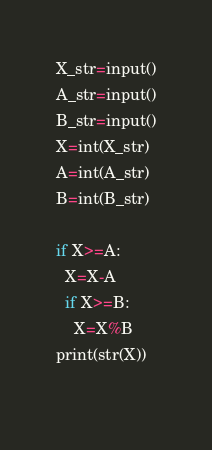<code> <loc_0><loc_0><loc_500><loc_500><_Python_>X_str=input()
A_str=input()
B_str=input()
X=int(X_str)
A=int(A_str)
B=int(B_str)

if X>=A:
  X=X-A
  if X>=B:
    X=X%B
print(str(X))
 </code> 